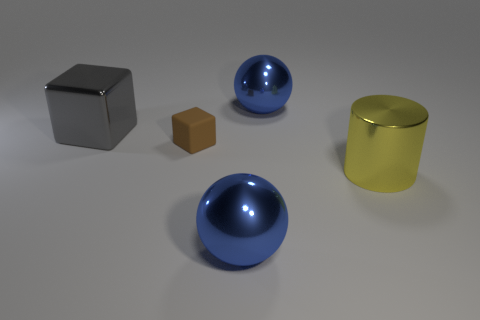Add 5 yellow objects. How many objects exist? 10 Subtract all spheres. How many objects are left? 3 Add 1 brown rubber blocks. How many brown rubber blocks exist? 2 Subtract 0 blue cylinders. How many objects are left? 5 Subtract all big cylinders. Subtract all brown things. How many objects are left? 3 Add 1 gray blocks. How many gray blocks are left? 2 